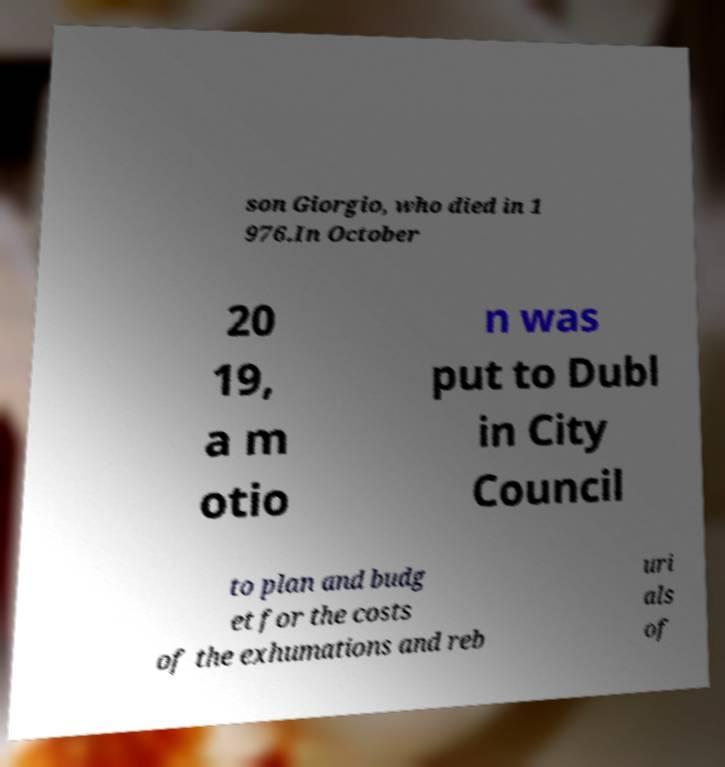For documentation purposes, I need the text within this image transcribed. Could you provide that? son Giorgio, who died in 1 976.In October 20 19, a m otio n was put to Dubl in City Council to plan and budg et for the costs of the exhumations and reb uri als of 